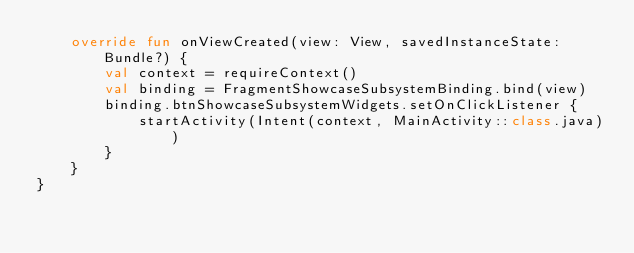<code> <loc_0><loc_0><loc_500><loc_500><_Kotlin_>    override fun onViewCreated(view: View, savedInstanceState: Bundle?) {
        val context = requireContext()
        val binding = FragmentShowcaseSubsystemBinding.bind(view)
        binding.btnShowcaseSubsystemWidgets.setOnClickListener {
            startActivity(Intent(context, MainActivity::class.java))
        }
    }
}
</code> 